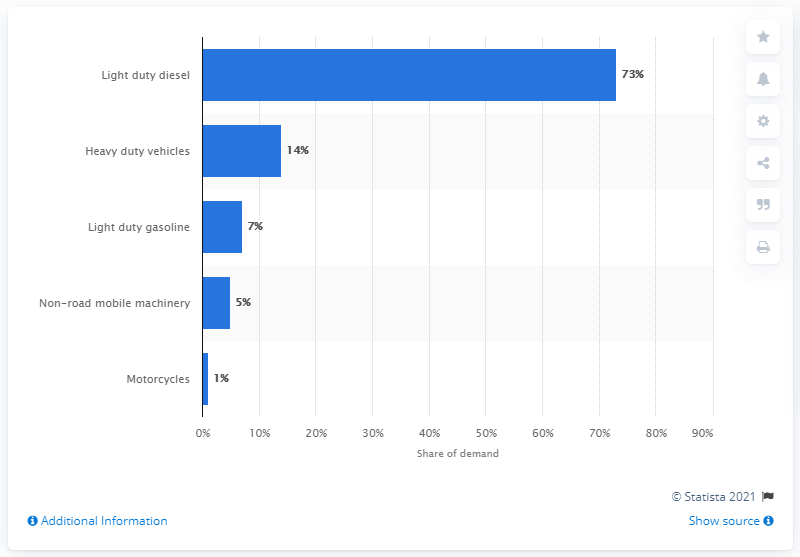Highlight a few significant elements in this photo. About 73% of the automobile industry's platinum demand was met by light duty diesel vehicles. 